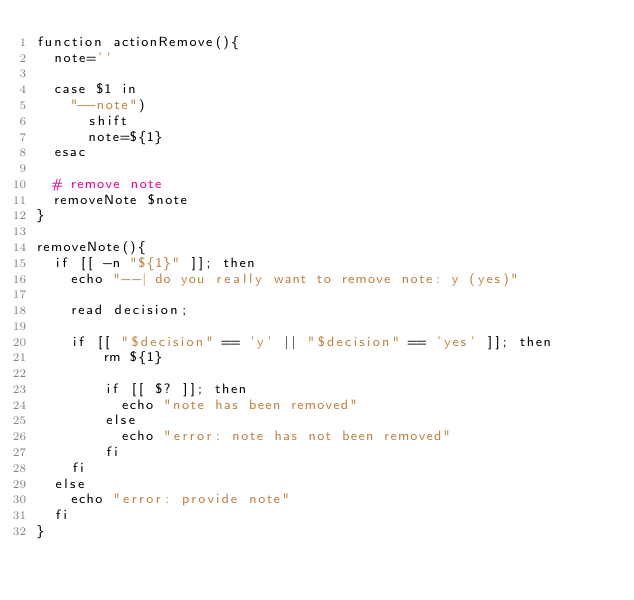Convert code to text. <code><loc_0><loc_0><loc_500><loc_500><_Bash_>function actionRemove(){
  note=''

  case $1 in
    "--note")
      shift
      note=${1}
  esac

  # remove note
  removeNote $note
}

removeNote(){
  if [[ -n "${1}" ]]; then
    echo "--| do you really want to remove note: y (yes)"

    read decision;

    if [[ "$decision" == 'y' || "$decision" == 'yes' ]]; then
        rm ${1}

        if [[ $? ]]; then
          echo "note has been removed"
        else
          echo "error: note has not been removed"
        fi
    fi
  else
    echo "error: provide note"
  fi
}
</code> 